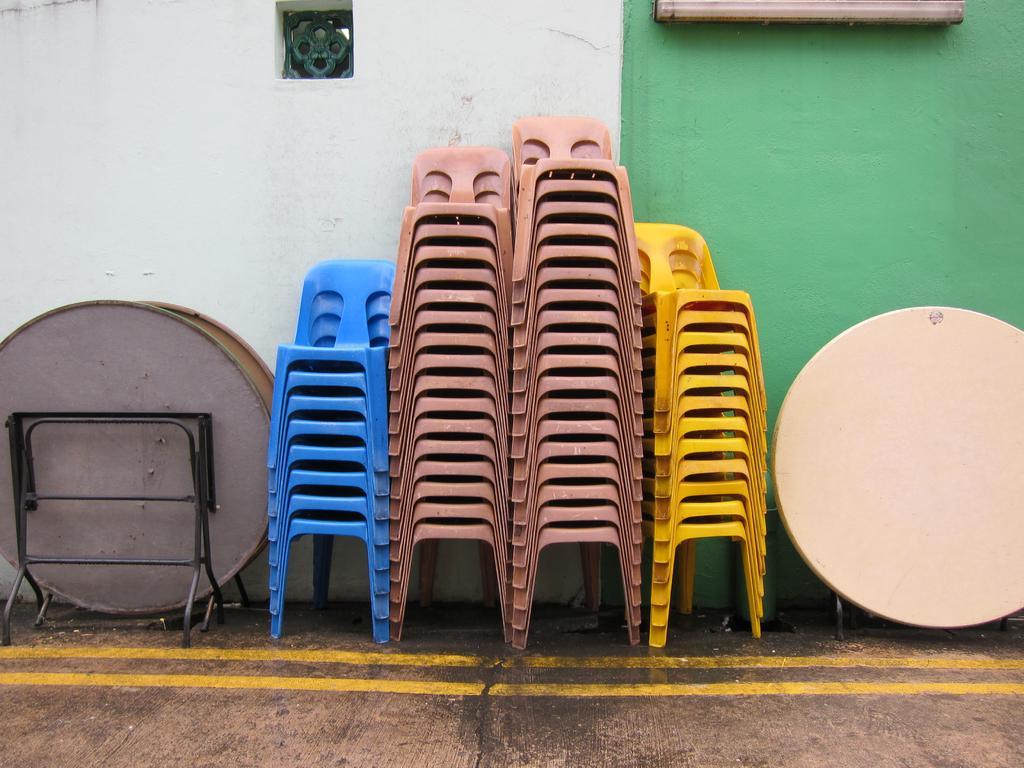Can you describe this image briefly? In this image we can see a group of chairs which are placed one on the other on the ground. We can also see some tables, a wall and a window. 